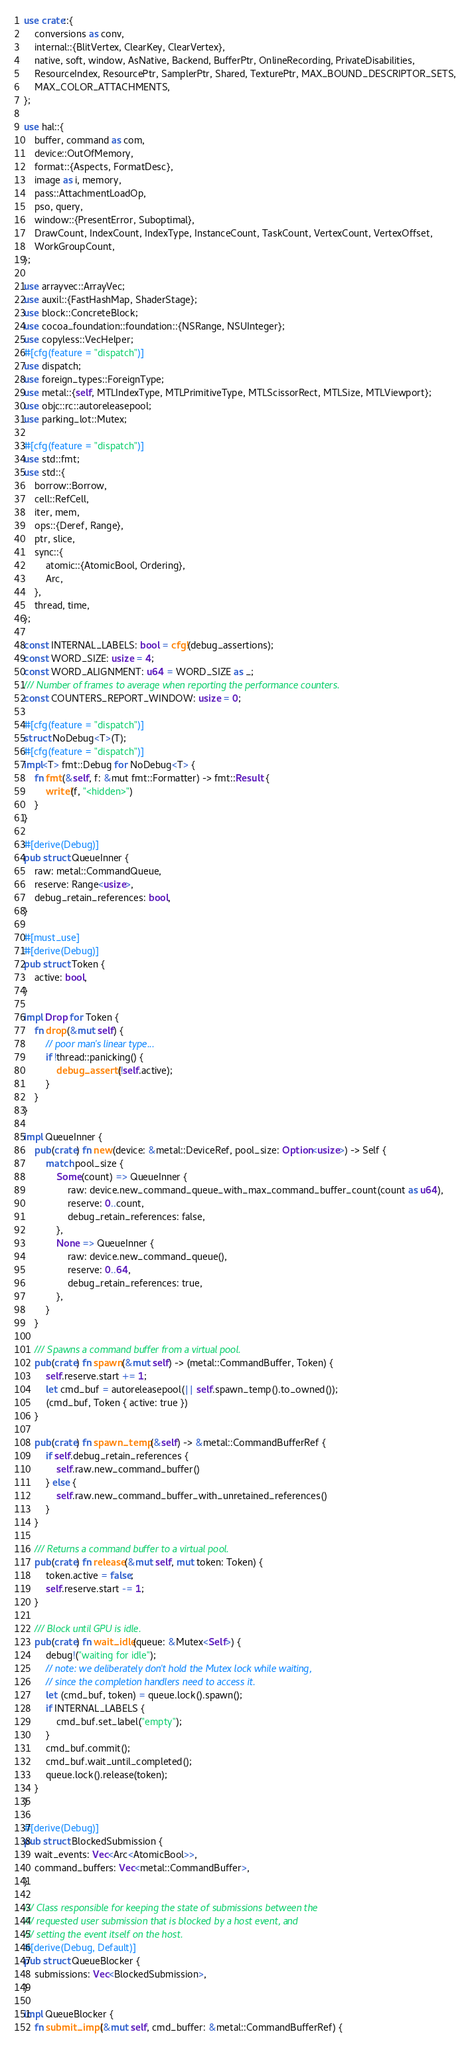Convert code to text. <code><loc_0><loc_0><loc_500><loc_500><_Rust_>use crate::{
    conversions as conv,
    internal::{BlitVertex, ClearKey, ClearVertex},
    native, soft, window, AsNative, Backend, BufferPtr, OnlineRecording, PrivateDisabilities,
    ResourceIndex, ResourcePtr, SamplerPtr, Shared, TexturePtr, MAX_BOUND_DESCRIPTOR_SETS,
    MAX_COLOR_ATTACHMENTS,
};

use hal::{
    buffer, command as com,
    device::OutOfMemory,
    format::{Aspects, FormatDesc},
    image as i, memory,
    pass::AttachmentLoadOp,
    pso, query,
    window::{PresentError, Suboptimal},
    DrawCount, IndexCount, IndexType, InstanceCount, TaskCount, VertexCount, VertexOffset,
    WorkGroupCount,
};

use arrayvec::ArrayVec;
use auxil::{FastHashMap, ShaderStage};
use block::ConcreteBlock;
use cocoa_foundation::foundation::{NSRange, NSUInteger};
use copyless::VecHelper;
#[cfg(feature = "dispatch")]
use dispatch;
use foreign_types::ForeignType;
use metal::{self, MTLIndexType, MTLPrimitiveType, MTLScissorRect, MTLSize, MTLViewport};
use objc::rc::autoreleasepool;
use parking_lot::Mutex;

#[cfg(feature = "dispatch")]
use std::fmt;
use std::{
    borrow::Borrow,
    cell::RefCell,
    iter, mem,
    ops::{Deref, Range},
    ptr, slice,
    sync::{
        atomic::{AtomicBool, Ordering},
        Arc,
    },
    thread, time,
};

const INTERNAL_LABELS: bool = cfg!(debug_assertions);
const WORD_SIZE: usize = 4;
const WORD_ALIGNMENT: u64 = WORD_SIZE as _;
/// Number of frames to average when reporting the performance counters.
const COUNTERS_REPORT_WINDOW: usize = 0;

#[cfg(feature = "dispatch")]
struct NoDebug<T>(T);
#[cfg(feature = "dispatch")]
impl<T> fmt::Debug for NoDebug<T> {
    fn fmt(&self, f: &mut fmt::Formatter) -> fmt::Result {
        write!(f, "<hidden>")
    }
}

#[derive(Debug)]
pub struct QueueInner {
    raw: metal::CommandQueue,
    reserve: Range<usize>,
    debug_retain_references: bool,
}

#[must_use]
#[derive(Debug)]
pub struct Token {
    active: bool,
}

impl Drop for Token {
    fn drop(&mut self) {
        // poor man's linear type...
        if !thread::panicking() {
            debug_assert!(!self.active);
        }
    }
}

impl QueueInner {
    pub(crate) fn new(device: &metal::DeviceRef, pool_size: Option<usize>) -> Self {
        match pool_size {
            Some(count) => QueueInner {
                raw: device.new_command_queue_with_max_command_buffer_count(count as u64),
                reserve: 0..count,
                debug_retain_references: false,
            },
            None => QueueInner {
                raw: device.new_command_queue(),
                reserve: 0..64,
                debug_retain_references: true,
            },
        }
    }

    /// Spawns a command buffer from a virtual pool.
    pub(crate) fn spawn(&mut self) -> (metal::CommandBuffer, Token) {
        self.reserve.start += 1;
        let cmd_buf = autoreleasepool(|| self.spawn_temp().to_owned());
        (cmd_buf, Token { active: true })
    }

    pub(crate) fn spawn_temp(&self) -> &metal::CommandBufferRef {
        if self.debug_retain_references {
            self.raw.new_command_buffer()
        } else {
            self.raw.new_command_buffer_with_unretained_references()
        }
    }

    /// Returns a command buffer to a virtual pool.
    pub(crate) fn release(&mut self, mut token: Token) {
        token.active = false;
        self.reserve.start -= 1;
    }

    /// Block until GPU is idle.
    pub(crate) fn wait_idle(queue: &Mutex<Self>) {
        debug!("waiting for idle");
        // note: we deliberately don't hold the Mutex lock while waiting,
        // since the completion handlers need to access it.
        let (cmd_buf, token) = queue.lock().spawn();
        if INTERNAL_LABELS {
            cmd_buf.set_label("empty");
        }
        cmd_buf.commit();
        cmd_buf.wait_until_completed();
        queue.lock().release(token);
    }
}

#[derive(Debug)]
pub struct BlockedSubmission {
    wait_events: Vec<Arc<AtomicBool>>,
    command_buffers: Vec<metal::CommandBuffer>,
}

/// Class responsible for keeping the state of submissions between the
/// requested user submission that is blocked by a host event, and
/// setting the event itself on the host.
#[derive(Debug, Default)]
pub struct QueueBlocker {
    submissions: Vec<BlockedSubmission>,
}

impl QueueBlocker {
    fn submit_impl(&mut self, cmd_buffer: &metal::CommandBufferRef) {</code> 